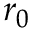<formula> <loc_0><loc_0><loc_500><loc_500>r _ { 0 }</formula> 